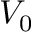<formula> <loc_0><loc_0><loc_500><loc_500>V _ { 0 }</formula> 